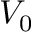<formula> <loc_0><loc_0><loc_500><loc_500>V _ { 0 }</formula> 